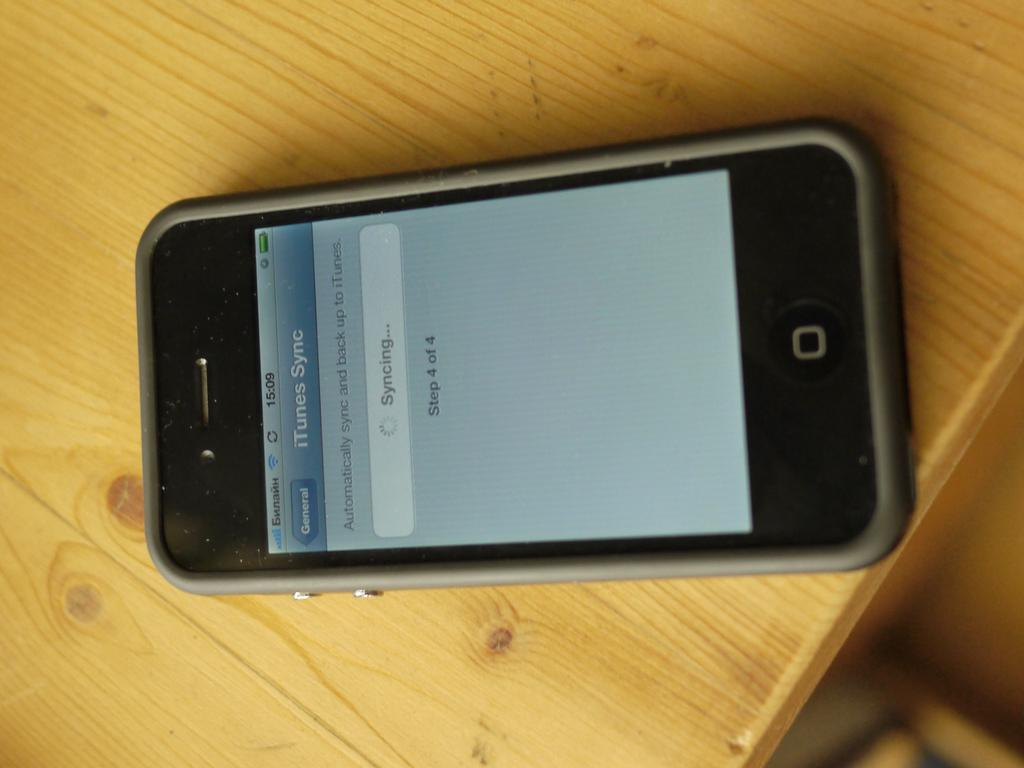Provide a one-sentence caption for the provided image. Older iphone that is syncing with itunes on a table. 